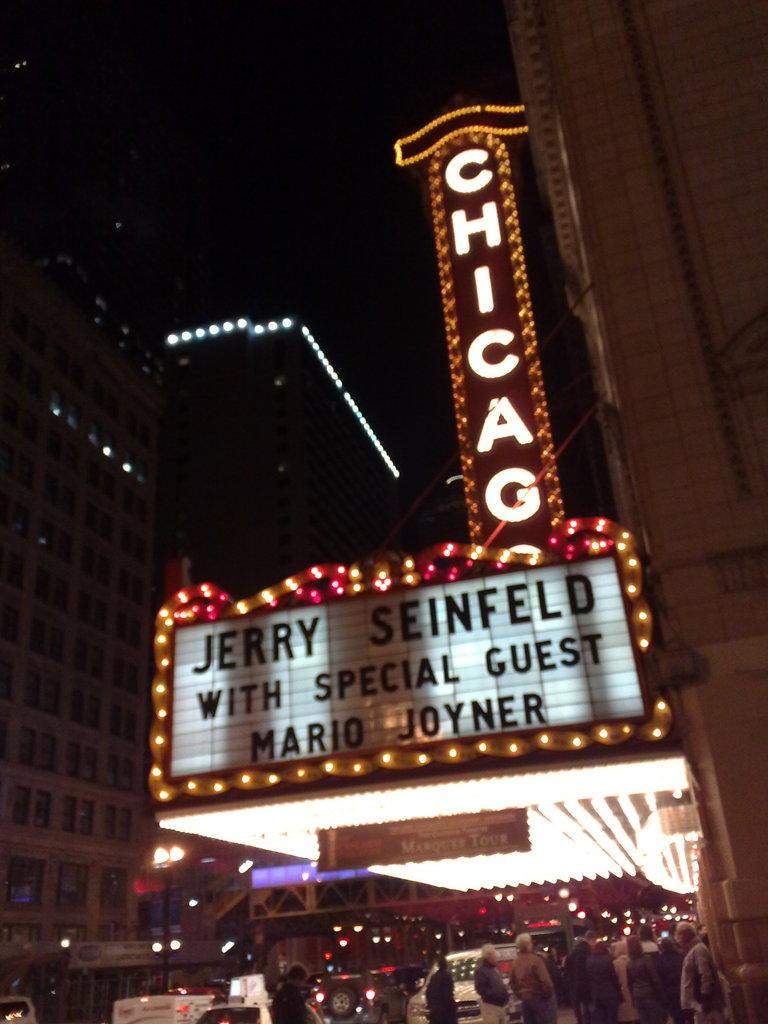What type of structures are visible in the image? There are buildings in the image. What else can be seen at the bottom of the image? There are persons and vehicles at the bottom of the image. Are there any illumination sources in the image? Yes, there are lights in the image. What is located in the center of the image? There are boards in the center of the image. What is written or displayed on the boards? There is text on the boards. What type of flower is growing on the top of the buildings in the image? There are no flowers visible on the buildings in the image. What hour of the day is depicted in the image? The provided facts do not give any information about the time of day, so it cannot be determined from the image. 